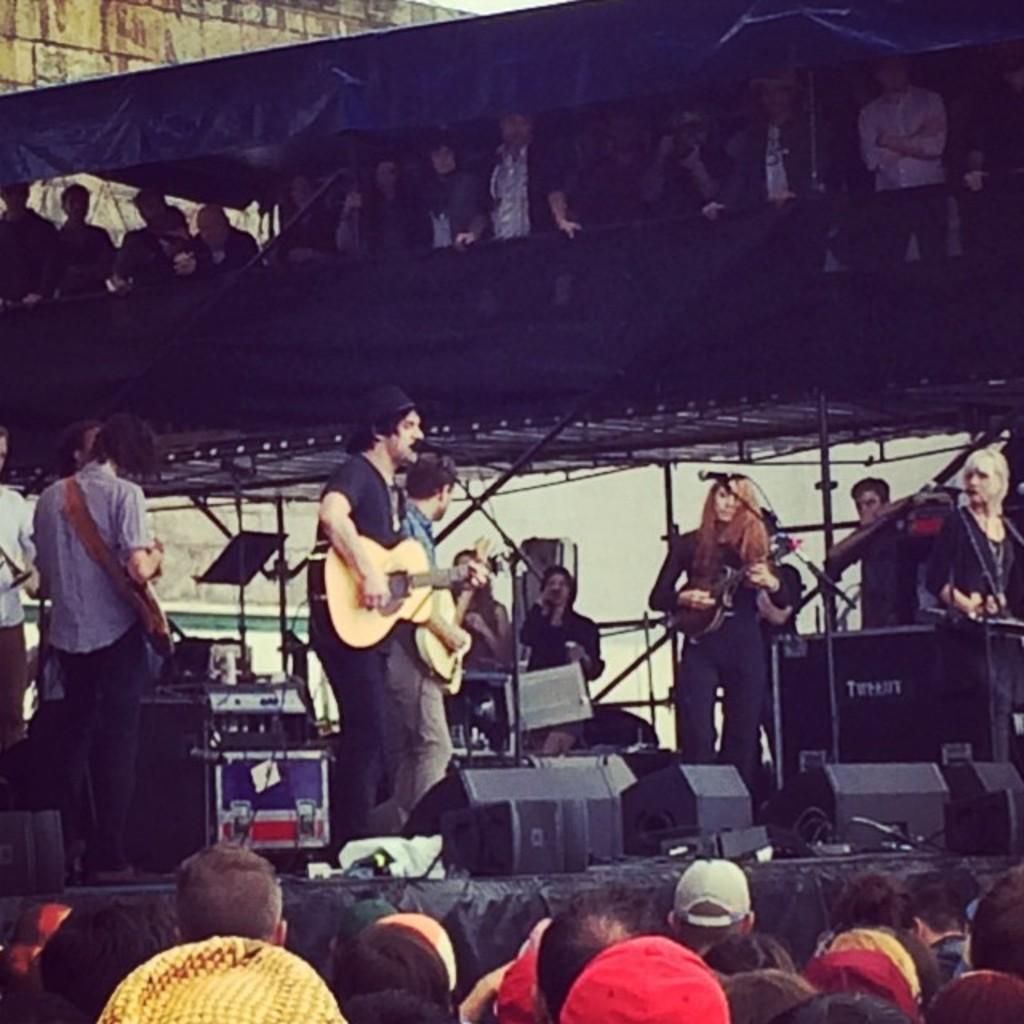Describe this image in one or two sentences. In this image there are group of people. There are three people standing on the stage and playing guitar. There are speakers, microphones, wires, boxes on the stage. 